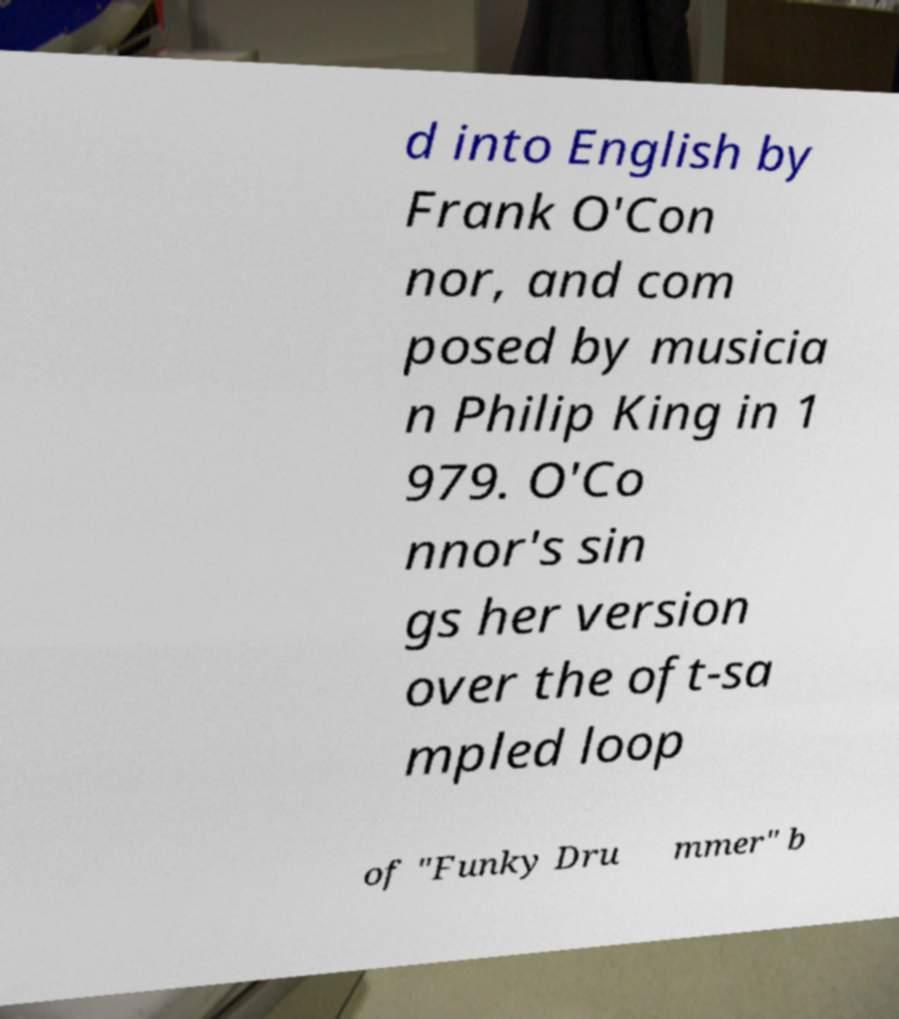Can you accurately transcribe the text from the provided image for me? d into English by Frank O'Con nor, and com posed by musicia n Philip King in 1 979. O'Co nnor's sin gs her version over the oft-sa mpled loop of "Funky Dru mmer" b 